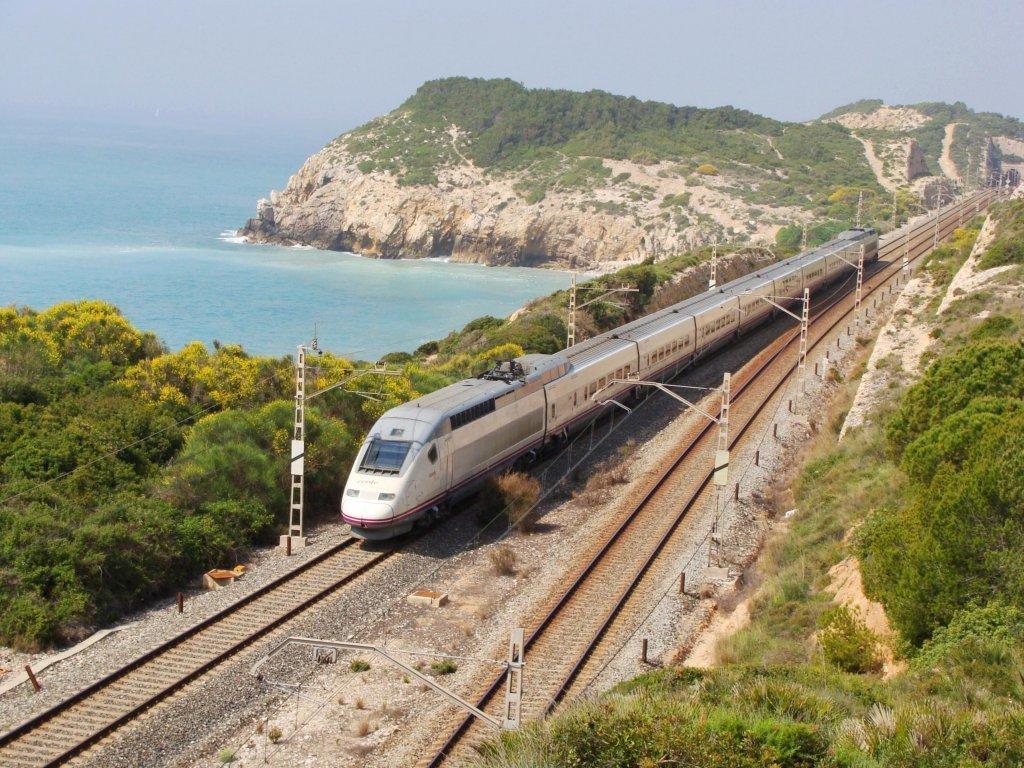Can you describe this image briefly? In this image I can see a train which is white and grey in color is on the railway track and I can see another railway track beside it. I can see few poles, few wires, few trees on both sides of the tracks and in the background I can see the water, a mountain and the sky. 